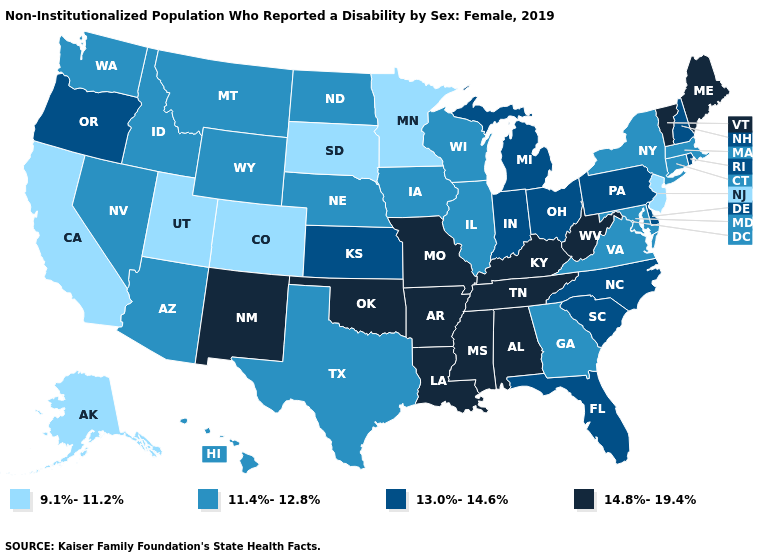What is the value of Connecticut?
Write a very short answer. 11.4%-12.8%. Does the map have missing data?
Short answer required. No. Does North Carolina have a higher value than Delaware?
Quick response, please. No. What is the value of Indiana?
Write a very short answer. 13.0%-14.6%. Among the states that border Georgia , which have the highest value?
Keep it brief. Alabama, Tennessee. Name the states that have a value in the range 13.0%-14.6%?
Answer briefly. Delaware, Florida, Indiana, Kansas, Michigan, New Hampshire, North Carolina, Ohio, Oregon, Pennsylvania, Rhode Island, South Carolina. Name the states that have a value in the range 9.1%-11.2%?
Quick response, please. Alaska, California, Colorado, Minnesota, New Jersey, South Dakota, Utah. What is the highest value in states that border Texas?
Concise answer only. 14.8%-19.4%. Which states have the highest value in the USA?
Quick response, please. Alabama, Arkansas, Kentucky, Louisiana, Maine, Mississippi, Missouri, New Mexico, Oklahoma, Tennessee, Vermont, West Virginia. Among the states that border Kansas , which have the lowest value?
Be succinct. Colorado. What is the value of Florida?
Keep it brief. 13.0%-14.6%. Does New Mexico have the highest value in the West?
Quick response, please. Yes. Among the states that border Connecticut , does Massachusetts have the lowest value?
Write a very short answer. Yes. What is the value of Florida?
Give a very brief answer. 13.0%-14.6%. Name the states that have a value in the range 13.0%-14.6%?
Write a very short answer. Delaware, Florida, Indiana, Kansas, Michigan, New Hampshire, North Carolina, Ohio, Oregon, Pennsylvania, Rhode Island, South Carolina. 